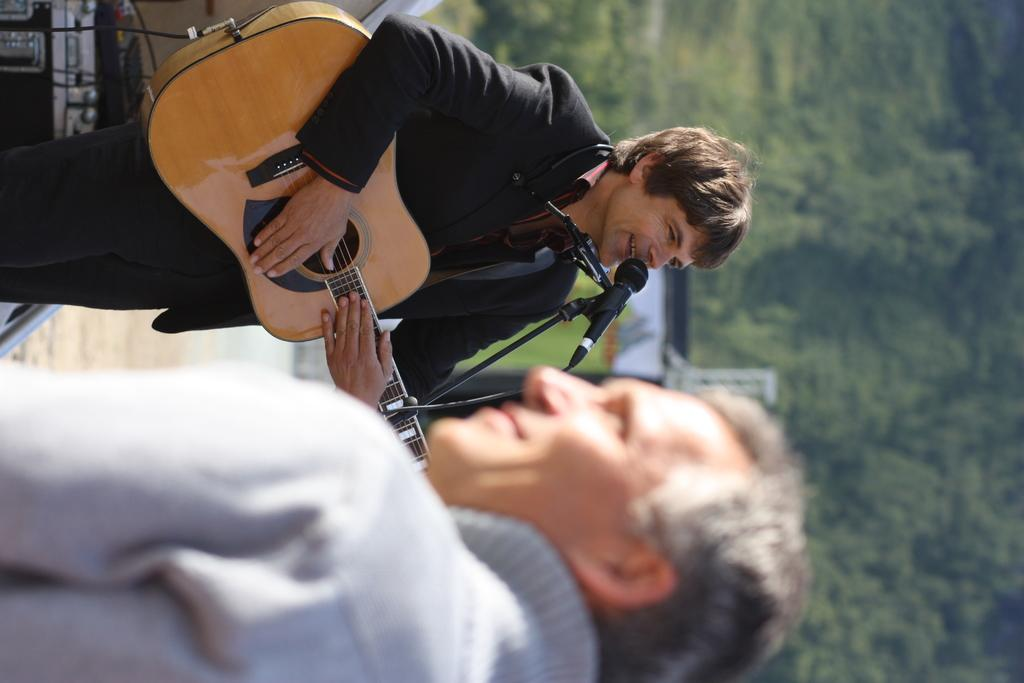How many people are present in the image? There are two people in the image. What object is visible in the image that is commonly used for amplifying sound? There is a mic in the image. What type of vegetation can be seen in the image? There are trees in the image. What instrument is one of the people holding? One person is holding a guitar. What type of jar is visible on the wheel in the image? There is no jar or wheel present in the image. 